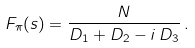<formula> <loc_0><loc_0><loc_500><loc_500>F _ { \pi } ( s ) = \frac { N } { D _ { 1 } + D _ { 2 } - i \, D _ { 3 } } \, .</formula> 